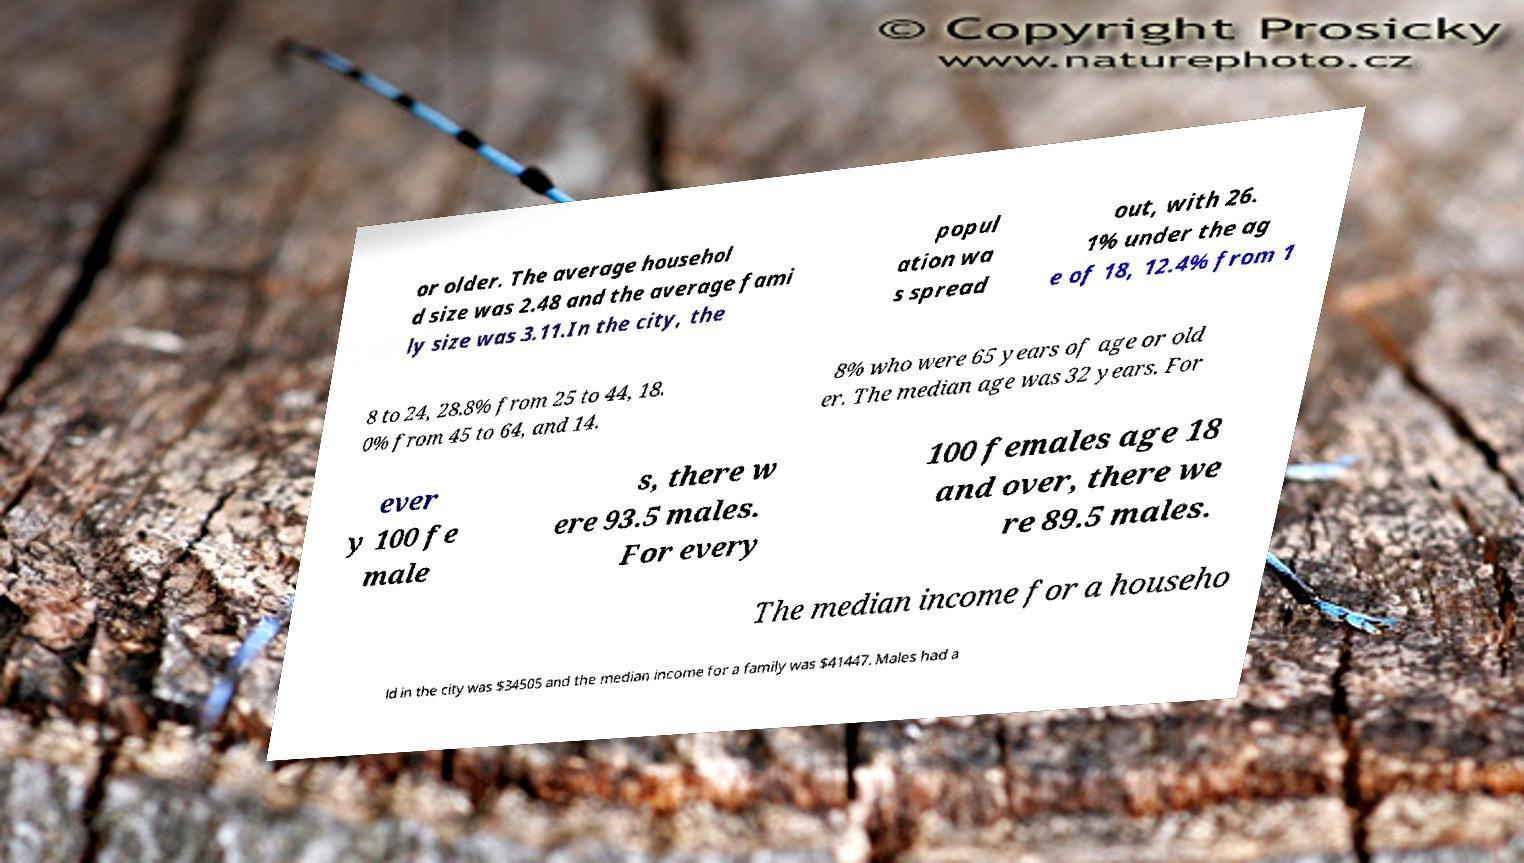Can you accurately transcribe the text from the provided image for me? or older. The average househol d size was 2.48 and the average fami ly size was 3.11.In the city, the popul ation wa s spread out, with 26. 1% under the ag e of 18, 12.4% from 1 8 to 24, 28.8% from 25 to 44, 18. 0% from 45 to 64, and 14. 8% who were 65 years of age or old er. The median age was 32 years. For ever y 100 fe male s, there w ere 93.5 males. For every 100 females age 18 and over, there we re 89.5 males. The median income for a househo ld in the city was $34505 and the median income for a family was $41447. Males had a 